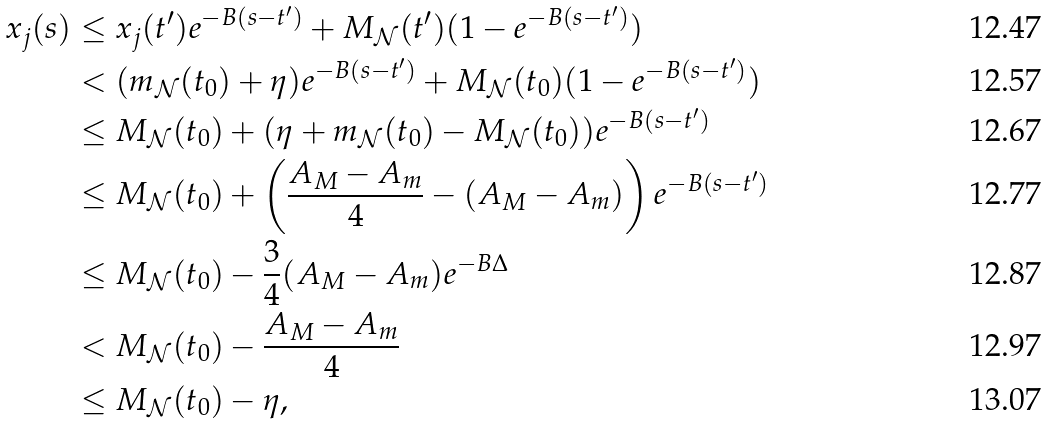<formula> <loc_0><loc_0><loc_500><loc_500>x _ { j } ( s ) & \leq x _ { j } ( t ^ { \prime } ) e ^ { - B ( s - t ^ { \prime } ) } + M _ { \mathcal { N } } ( t ^ { \prime } ) ( 1 - e ^ { - B ( s - t ^ { \prime } ) } ) \\ & < ( m _ { \mathcal { N } } ( t _ { 0 } ) + \eta ) e ^ { - B ( s - t ^ { \prime } ) } + M _ { \mathcal { N } } ( t _ { 0 } ) ( 1 - e ^ { - B ( s - t ^ { \prime } ) } ) \\ & \leq M _ { \mathcal { N } } ( t _ { 0 } ) + ( \eta + m _ { \mathcal { N } } ( t _ { 0 } ) - M _ { \mathcal { N } } ( t _ { 0 } ) ) e ^ { - B ( s - t ^ { \prime } ) } \\ & \leq M _ { \mathcal { N } } ( t _ { 0 } ) + \left ( \frac { A _ { M } - A _ { m } } { 4 } - ( A _ { M } - A _ { m } ) \right ) e ^ { - B ( s - t ^ { \prime } ) } \\ & \leq M _ { \mathcal { N } } ( t _ { 0 } ) - \frac { 3 } { 4 } ( A _ { M } - A _ { m } ) e ^ { - B \Delta } \\ & < M _ { \mathcal { N } } ( t _ { 0 } ) - \frac { A _ { M } - A _ { m } } { 4 } \\ & \leq M _ { \mathcal { N } } ( t _ { 0 } ) - \eta ,</formula> 